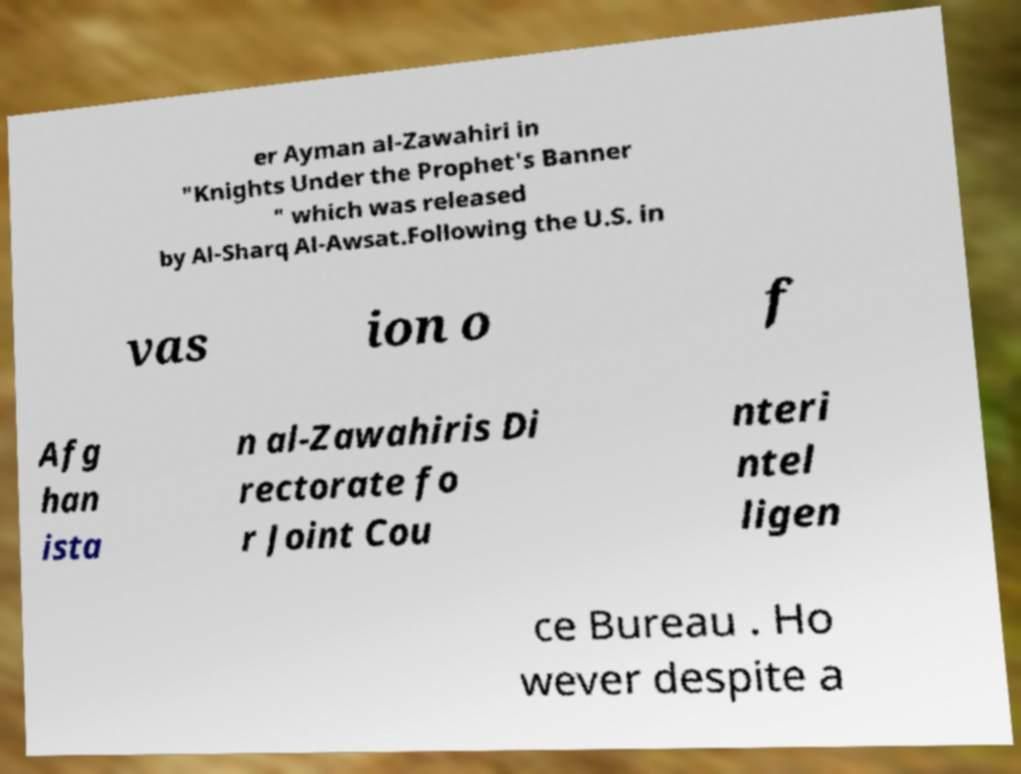Can you accurately transcribe the text from the provided image for me? er Ayman al-Zawahiri in "Knights Under the Prophet's Banner " which was released by Al-Sharq Al-Awsat.Following the U.S. in vas ion o f Afg han ista n al-Zawahiris Di rectorate fo r Joint Cou nteri ntel ligen ce Bureau . Ho wever despite a 